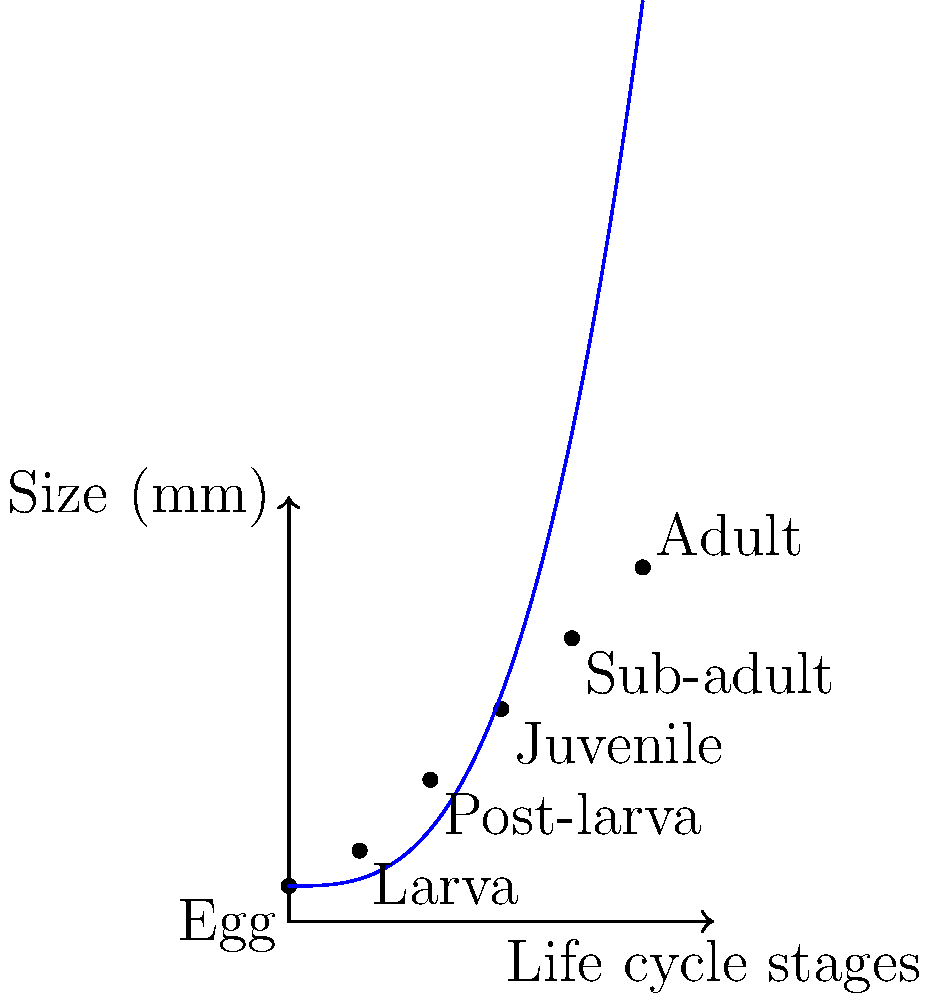Based on the growth curve shown in the diagram, which life cycle stage of the common goby species exhibits the most rapid increase in size? To determine which life cycle stage exhibits the most rapid increase in size, we need to analyze the slope of the growth curve between each stage:

1. Egg to Larva: Slight increase, low slope
2. Larva to Post-larva: Moderate increase, slightly steeper slope
3. Post-larva to Juvenile: Steeper increase, slope becoming more pronounced
4. Juvenile to Sub-adult: Steep increase, high slope
5. Sub-adult to Adult: Steepest increase, highest slope

The steepness of the curve represents the rate of growth. The steeper the curve, the more rapid the increase in size. 

From the diagram, we can observe that the curve becomes increasingly steeper as it progresses through the life cycle stages. The steepest part of the curve, indicating the most rapid increase in size, occurs between the Sub-adult and Adult stages.

Therefore, the life cycle stage that exhibits the most rapid increase in size is the transition from Sub-adult to Adult.
Answer: Sub-adult to Adult 